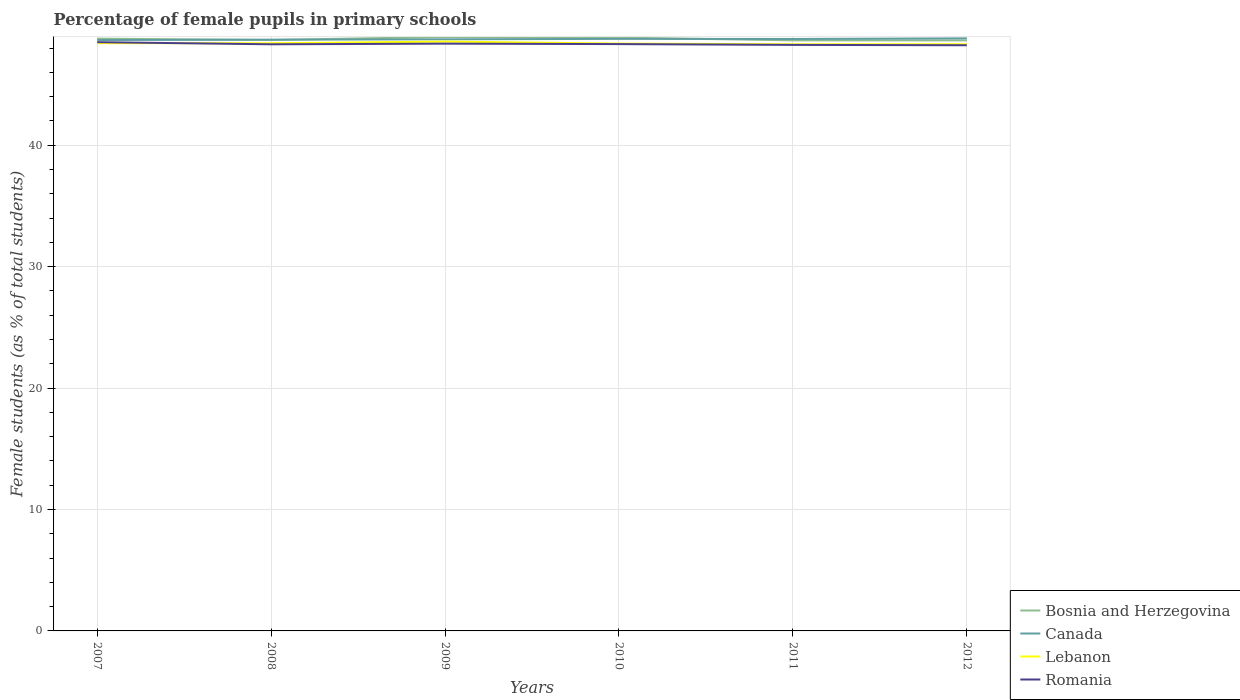How many different coloured lines are there?
Provide a succinct answer. 4. Does the line corresponding to Bosnia and Herzegovina intersect with the line corresponding to Romania?
Offer a very short reply. No. Is the number of lines equal to the number of legend labels?
Give a very brief answer. Yes. Across all years, what is the maximum percentage of female pupils in primary schools in Bosnia and Herzegovina?
Ensure brevity in your answer.  48.63. What is the total percentage of female pupils in primary schools in Romania in the graph?
Your response must be concise. 0.04. What is the difference between the highest and the second highest percentage of female pupils in primary schools in Romania?
Ensure brevity in your answer.  0.25. What is the difference between the highest and the lowest percentage of female pupils in primary schools in Lebanon?
Make the answer very short. 3. Is the percentage of female pupils in primary schools in Romania strictly greater than the percentage of female pupils in primary schools in Bosnia and Herzegovina over the years?
Offer a terse response. Yes. How many lines are there?
Offer a very short reply. 4. How many years are there in the graph?
Provide a succinct answer. 6. What is the difference between two consecutive major ticks on the Y-axis?
Ensure brevity in your answer.  10. How are the legend labels stacked?
Your answer should be very brief. Vertical. What is the title of the graph?
Make the answer very short. Percentage of female pupils in primary schools. What is the label or title of the Y-axis?
Provide a short and direct response. Female students (as % of total students). What is the Female students (as % of total students) of Bosnia and Herzegovina in 2007?
Keep it short and to the point. 48.77. What is the Female students (as % of total students) of Canada in 2007?
Your answer should be compact. 48.66. What is the Female students (as % of total students) in Lebanon in 2007?
Make the answer very short. 48.4. What is the Female students (as % of total students) in Romania in 2007?
Provide a short and direct response. 48.49. What is the Female students (as % of total students) of Bosnia and Herzegovina in 2008?
Keep it short and to the point. 48.67. What is the Female students (as % of total students) of Canada in 2008?
Your answer should be compact. 48.69. What is the Female students (as % of total students) in Lebanon in 2008?
Offer a very short reply. 48.4. What is the Female students (as % of total students) of Romania in 2008?
Your answer should be very brief. 48.31. What is the Female students (as % of total students) in Bosnia and Herzegovina in 2009?
Make the answer very short. 48.91. What is the Female students (as % of total students) in Canada in 2009?
Your answer should be compact. 48.72. What is the Female students (as % of total students) of Lebanon in 2009?
Your answer should be very brief. 48.53. What is the Female students (as % of total students) of Romania in 2009?
Make the answer very short. 48.36. What is the Female students (as % of total students) of Bosnia and Herzegovina in 2010?
Provide a short and direct response. 48.86. What is the Female students (as % of total students) of Canada in 2010?
Make the answer very short. 48.76. What is the Female students (as % of total students) in Lebanon in 2010?
Give a very brief answer. 48.37. What is the Female students (as % of total students) in Romania in 2010?
Provide a short and direct response. 48.33. What is the Female students (as % of total students) of Bosnia and Herzegovina in 2011?
Offer a very short reply. 48.63. What is the Female students (as % of total students) of Canada in 2011?
Ensure brevity in your answer.  48.75. What is the Female students (as % of total students) of Lebanon in 2011?
Keep it short and to the point. 48.31. What is the Female students (as % of total students) of Romania in 2011?
Your answer should be very brief. 48.26. What is the Female students (as % of total students) in Bosnia and Herzegovina in 2012?
Your response must be concise. 48.63. What is the Female students (as % of total students) in Canada in 2012?
Your response must be concise. 48.8. What is the Female students (as % of total students) of Lebanon in 2012?
Keep it short and to the point. 48.31. What is the Female students (as % of total students) of Romania in 2012?
Make the answer very short. 48.23. Across all years, what is the maximum Female students (as % of total students) in Bosnia and Herzegovina?
Provide a succinct answer. 48.91. Across all years, what is the maximum Female students (as % of total students) in Canada?
Keep it short and to the point. 48.8. Across all years, what is the maximum Female students (as % of total students) in Lebanon?
Provide a short and direct response. 48.53. Across all years, what is the maximum Female students (as % of total students) of Romania?
Make the answer very short. 48.49. Across all years, what is the minimum Female students (as % of total students) of Bosnia and Herzegovina?
Give a very brief answer. 48.63. Across all years, what is the minimum Female students (as % of total students) in Canada?
Your response must be concise. 48.66. Across all years, what is the minimum Female students (as % of total students) in Lebanon?
Provide a short and direct response. 48.31. Across all years, what is the minimum Female students (as % of total students) in Romania?
Your answer should be compact. 48.23. What is the total Female students (as % of total students) in Bosnia and Herzegovina in the graph?
Offer a terse response. 292.48. What is the total Female students (as % of total students) in Canada in the graph?
Your answer should be compact. 292.37. What is the total Female students (as % of total students) in Lebanon in the graph?
Offer a terse response. 290.33. What is the total Female students (as % of total students) of Romania in the graph?
Ensure brevity in your answer.  289.98. What is the difference between the Female students (as % of total students) of Bosnia and Herzegovina in 2007 and that in 2008?
Your answer should be compact. 0.1. What is the difference between the Female students (as % of total students) of Canada in 2007 and that in 2008?
Your answer should be very brief. -0.03. What is the difference between the Female students (as % of total students) in Lebanon in 2007 and that in 2008?
Provide a succinct answer. 0.01. What is the difference between the Female students (as % of total students) in Romania in 2007 and that in 2008?
Offer a terse response. 0.18. What is the difference between the Female students (as % of total students) of Bosnia and Herzegovina in 2007 and that in 2009?
Offer a very short reply. -0.14. What is the difference between the Female students (as % of total students) of Canada in 2007 and that in 2009?
Keep it short and to the point. -0.06. What is the difference between the Female students (as % of total students) of Lebanon in 2007 and that in 2009?
Your response must be concise. -0.13. What is the difference between the Female students (as % of total students) of Romania in 2007 and that in 2009?
Your response must be concise. 0.12. What is the difference between the Female students (as % of total students) of Bosnia and Herzegovina in 2007 and that in 2010?
Offer a very short reply. -0.09. What is the difference between the Female students (as % of total students) of Canada in 2007 and that in 2010?
Keep it short and to the point. -0.09. What is the difference between the Female students (as % of total students) of Lebanon in 2007 and that in 2010?
Ensure brevity in your answer.  0.04. What is the difference between the Female students (as % of total students) of Romania in 2007 and that in 2010?
Provide a short and direct response. 0.16. What is the difference between the Female students (as % of total students) in Bosnia and Herzegovina in 2007 and that in 2011?
Give a very brief answer. 0.14. What is the difference between the Female students (as % of total students) of Canada in 2007 and that in 2011?
Your answer should be very brief. -0.08. What is the difference between the Female students (as % of total students) in Lebanon in 2007 and that in 2011?
Your answer should be very brief. 0.09. What is the difference between the Female students (as % of total students) in Romania in 2007 and that in 2011?
Provide a short and direct response. 0.22. What is the difference between the Female students (as % of total students) in Bosnia and Herzegovina in 2007 and that in 2012?
Offer a terse response. 0.14. What is the difference between the Female students (as % of total students) of Canada in 2007 and that in 2012?
Make the answer very short. -0.14. What is the difference between the Female students (as % of total students) in Lebanon in 2007 and that in 2012?
Ensure brevity in your answer.  0.09. What is the difference between the Female students (as % of total students) of Romania in 2007 and that in 2012?
Offer a very short reply. 0.25. What is the difference between the Female students (as % of total students) of Bosnia and Herzegovina in 2008 and that in 2009?
Provide a succinct answer. -0.24. What is the difference between the Female students (as % of total students) in Canada in 2008 and that in 2009?
Ensure brevity in your answer.  -0.03. What is the difference between the Female students (as % of total students) of Lebanon in 2008 and that in 2009?
Ensure brevity in your answer.  -0.14. What is the difference between the Female students (as % of total students) of Romania in 2008 and that in 2009?
Ensure brevity in your answer.  -0.05. What is the difference between the Female students (as % of total students) in Bosnia and Herzegovina in 2008 and that in 2010?
Provide a succinct answer. -0.19. What is the difference between the Female students (as % of total students) of Canada in 2008 and that in 2010?
Offer a terse response. -0.07. What is the difference between the Female students (as % of total students) of Lebanon in 2008 and that in 2010?
Provide a short and direct response. 0.03. What is the difference between the Female students (as % of total students) of Romania in 2008 and that in 2010?
Make the answer very short. -0.02. What is the difference between the Female students (as % of total students) in Bosnia and Herzegovina in 2008 and that in 2011?
Your answer should be compact. 0.03. What is the difference between the Female students (as % of total students) in Canada in 2008 and that in 2011?
Keep it short and to the point. -0.06. What is the difference between the Female students (as % of total students) in Lebanon in 2008 and that in 2011?
Your answer should be compact. 0.08. What is the difference between the Female students (as % of total students) in Romania in 2008 and that in 2011?
Give a very brief answer. 0.05. What is the difference between the Female students (as % of total students) of Bosnia and Herzegovina in 2008 and that in 2012?
Offer a very short reply. 0.04. What is the difference between the Female students (as % of total students) in Canada in 2008 and that in 2012?
Provide a short and direct response. -0.11. What is the difference between the Female students (as % of total students) of Lebanon in 2008 and that in 2012?
Ensure brevity in your answer.  0.08. What is the difference between the Female students (as % of total students) in Romania in 2008 and that in 2012?
Your answer should be very brief. 0.08. What is the difference between the Female students (as % of total students) in Bosnia and Herzegovina in 2009 and that in 2010?
Make the answer very short. 0.05. What is the difference between the Female students (as % of total students) in Canada in 2009 and that in 2010?
Your answer should be very brief. -0.04. What is the difference between the Female students (as % of total students) in Lebanon in 2009 and that in 2010?
Your answer should be compact. 0.16. What is the difference between the Female students (as % of total students) in Romania in 2009 and that in 2010?
Give a very brief answer. 0.04. What is the difference between the Female students (as % of total students) in Bosnia and Herzegovina in 2009 and that in 2011?
Offer a very short reply. 0.28. What is the difference between the Female students (as % of total students) in Canada in 2009 and that in 2011?
Make the answer very short. -0.03. What is the difference between the Female students (as % of total students) in Lebanon in 2009 and that in 2011?
Provide a short and direct response. 0.22. What is the difference between the Female students (as % of total students) in Romania in 2009 and that in 2011?
Provide a succinct answer. 0.1. What is the difference between the Female students (as % of total students) of Bosnia and Herzegovina in 2009 and that in 2012?
Provide a succinct answer. 0.28. What is the difference between the Female students (as % of total students) in Canada in 2009 and that in 2012?
Your answer should be compact. -0.08. What is the difference between the Female students (as % of total students) of Lebanon in 2009 and that in 2012?
Offer a very short reply. 0.22. What is the difference between the Female students (as % of total students) of Romania in 2009 and that in 2012?
Offer a terse response. 0.13. What is the difference between the Female students (as % of total students) of Bosnia and Herzegovina in 2010 and that in 2011?
Provide a succinct answer. 0.23. What is the difference between the Female students (as % of total students) of Canada in 2010 and that in 2011?
Keep it short and to the point. 0.01. What is the difference between the Female students (as % of total students) in Lebanon in 2010 and that in 2011?
Ensure brevity in your answer.  0.06. What is the difference between the Female students (as % of total students) of Romania in 2010 and that in 2011?
Your response must be concise. 0.07. What is the difference between the Female students (as % of total students) of Bosnia and Herzegovina in 2010 and that in 2012?
Provide a succinct answer. 0.23. What is the difference between the Female students (as % of total students) of Canada in 2010 and that in 2012?
Make the answer very short. -0.04. What is the difference between the Female students (as % of total students) of Lebanon in 2010 and that in 2012?
Ensure brevity in your answer.  0.05. What is the difference between the Female students (as % of total students) of Romania in 2010 and that in 2012?
Your response must be concise. 0.1. What is the difference between the Female students (as % of total students) of Bosnia and Herzegovina in 2011 and that in 2012?
Provide a short and direct response. 0. What is the difference between the Female students (as % of total students) of Canada in 2011 and that in 2012?
Your response must be concise. -0.05. What is the difference between the Female students (as % of total students) of Lebanon in 2011 and that in 2012?
Give a very brief answer. -0. What is the difference between the Female students (as % of total students) in Romania in 2011 and that in 2012?
Your answer should be very brief. 0.03. What is the difference between the Female students (as % of total students) of Bosnia and Herzegovina in 2007 and the Female students (as % of total students) of Canada in 2008?
Offer a terse response. 0.08. What is the difference between the Female students (as % of total students) in Bosnia and Herzegovina in 2007 and the Female students (as % of total students) in Lebanon in 2008?
Give a very brief answer. 0.38. What is the difference between the Female students (as % of total students) of Bosnia and Herzegovina in 2007 and the Female students (as % of total students) of Romania in 2008?
Offer a terse response. 0.46. What is the difference between the Female students (as % of total students) in Canada in 2007 and the Female students (as % of total students) in Lebanon in 2008?
Give a very brief answer. 0.27. What is the difference between the Female students (as % of total students) of Canada in 2007 and the Female students (as % of total students) of Romania in 2008?
Offer a terse response. 0.35. What is the difference between the Female students (as % of total students) of Lebanon in 2007 and the Female students (as % of total students) of Romania in 2008?
Provide a short and direct response. 0.1. What is the difference between the Female students (as % of total students) of Bosnia and Herzegovina in 2007 and the Female students (as % of total students) of Canada in 2009?
Keep it short and to the point. 0.05. What is the difference between the Female students (as % of total students) of Bosnia and Herzegovina in 2007 and the Female students (as % of total students) of Lebanon in 2009?
Your answer should be very brief. 0.24. What is the difference between the Female students (as % of total students) in Bosnia and Herzegovina in 2007 and the Female students (as % of total students) in Romania in 2009?
Provide a short and direct response. 0.41. What is the difference between the Female students (as % of total students) in Canada in 2007 and the Female students (as % of total students) in Lebanon in 2009?
Provide a succinct answer. 0.13. What is the difference between the Female students (as % of total students) in Canada in 2007 and the Female students (as % of total students) in Romania in 2009?
Give a very brief answer. 0.3. What is the difference between the Female students (as % of total students) in Lebanon in 2007 and the Female students (as % of total students) in Romania in 2009?
Offer a very short reply. 0.04. What is the difference between the Female students (as % of total students) of Bosnia and Herzegovina in 2007 and the Female students (as % of total students) of Canada in 2010?
Ensure brevity in your answer.  0.02. What is the difference between the Female students (as % of total students) of Bosnia and Herzegovina in 2007 and the Female students (as % of total students) of Lebanon in 2010?
Ensure brevity in your answer.  0.4. What is the difference between the Female students (as % of total students) of Bosnia and Herzegovina in 2007 and the Female students (as % of total students) of Romania in 2010?
Keep it short and to the point. 0.45. What is the difference between the Female students (as % of total students) of Canada in 2007 and the Female students (as % of total students) of Lebanon in 2010?
Make the answer very short. 0.29. What is the difference between the Female students (as % of total students) in Canada in 2007 and the Female students (as % of total students) in Romania in 2010?
Provide a short and direct response. 0.34. What is the difference between the Female students (as % of total students) in Lebanon in 2007 and the Female students (as % of total students) in Romania in 2010?
Make the answer very short. 0.08. What is the difference between the Female students (as % of total students) in Bosnia and Herzegovina in 2007 and the Female students (as % of total students) in Canada in 2011?
Keep it short and to the point. 0.03. What is the difference between the Female students (as % of total students) in Bosnia and Herzegovina in 2007 and the Female students (as % of total students) in Lebanon in 2011?
Your answer should be compact. 0.46. What is the difference between the Female students (as % of total students) in Bosnia and Herzegovina in 2007 and the Female students (as % of total students) in Romania in 2011?
Your response must be concise. 0.51. What is the difference between the Female students (as % of total students) in Canada in 2007 and the Female students (as % of total students) in Lebanon in 2011?
Your answer should be very brief. 0.35. What is the difference between the Female students (as % of total students) in Canada in 2007 and the Female students (as % of total students) in Romania in 2011?
Provide a short and direct response. 0.4. What is the difference between the Female students (as % of total students) in Lebanon in 2007 and the Female students (as % of total students) in Romania in 2011?
Your answer should be compact. 0.14. What is the difference between the Female students (as % of total students) of Bosnia and Herzegovina in 2007 and the Female students (as % of total students) of Canada in 2012?
Your answer should be very brief. -0.03. What is the difference between the Female students (as % of total students) of Bosnia and Herzegovina in 2007 and the Female students (as % of total students) of Lebanon in 2012?
Offer a very short reply. 0.46. What is the difference between the Female students (as % of total students) of Bosnia and Herzegovina in 2007 and the Female students (as % of total students) of Romania in 2012?
Keep it short and to the point. 0.54. What is the difference between the Female students (as % of total students) of Canada in 2007 and the Female students (as % of total students) of Lebanon in 2012?
Your response must be concise. 0.35. What is the difference between the Female students (as % of total students) of Canada in 2007 and the Female students (as % of total students) of Romania in 2012?
Your response must be concise. 0.43. What is the difference between the Female students (as % of total students) in Lebanon in 2007 and the Female students (as % of total students) in Romania in 2012?
Provide a short and direct response. 0.17. What is the difference between the Female students (as % of total students) in Bosnia and Herzegovina in 2008 and the Female students (as % of total students) in Canada in 2009?
Your response must be concise. -0.05. What is the difference between the Female students (as % of total students) of Bosnia and Herzegovina in 2008 and the Female students (as % of total students) of Lebanon in 2009?
Your answer should be compact. 0.14. What is the difference between the Female students (as % of total students) of Bosnia and Herzegovina in 2008 and the Female students (as % of total students) of Romania in 2009?
Offer a very short reply. 0.31. What is the difference between the Female students (as % of total students) in Canada in 2008 and the Female students (as % of total students) in Lebanon in 2009?
Keep it short and to the point. 0.16. What is the difference between the Female students (as % of total students) of Canada in 2008 and the Female students (as % of total students) of Romania in 2009?
Make the answer very short. 0.33. What is the difference between the Female students (as % of total students) in Lebanon in 2008 and the Female students (as % of total students) in Romania in 2009?
Offer a very short reply. 0.03. What is the difference between the Female students (as % of total students) of Bosnia and Herzegovina in 2008 and the Female students (as % of total students) of Canada in 2010?
Provide a succinct answer. -0.09. What is the difference between the Female students (as % of total students) in Bosnia and Herzegovina in 2008 and the Female students (as % of total students) in Lebanon in 2010?
Offer a very short reply. 0.3. What is the difference between the Female students (as % of total students) in Bosnia and Herzegovina in 2008 and the Female students (as % of total students) in Romania in 2010?
Make the answer very short. 0.34. What is the difference between the Female students (as % of total students) in Canada in 2008 and the Female students (as % of total students) in Lebanon in 2010?
Your answer should be compact. 0.32. What is the difference between the Female students (as % of total students) in Canada in 2008 and the Female students (as % of total students) in Romania in 2010?
Keep it short and to the point. 0.36. What is the difference between the Female students (as % of total students) of Lebanon in 2008 and the Female students (as % of total students) of Romania in 2010?
Your answer should be very brief. 0.07. What is the difference between the Female students (as % of total students) of Bosnia and Herzegovina in 2008 and the Female students (as % of total students) of Canada in 2011?
Your answer should be compact. -0.08. What is the difference between the Female students (as % of total students) of Bosnia and Herzegovina in 2008 and the Female students (as % of total students) of Lebanon in 2011?
Offer a very short reply. 0.36. What is the difference between the Female students (as % of total students) in Bosnia and Herzegovina in 2008 and the Female students (as % of total students) in Romania in 2011?
Ensure brevity in your answer.  0.41. What is the difference between the Female students (as % of total students) in Canada in 2008 and the Female students (as % of total students) in Lebanon in 2011?
Ensure brevity in your answer.  0.38. What is the difference between the Female students (as % of total students) in Canada in 2008 and the Female students (as % of total students) in Romania in 2011?
Provide a succinct answer. 0.43. What is the difference between the Female students (as % of total students) in Lebanon in 2008 and the Female students (as % of total students) in Romania in 2011?
Provide a succinct answer. 0.14. What is the difference between the Female students (as % of total students) of Bosnia and Herzegovina in 2008 and the Female students (as % of total students) of Canada in 2012?
Your answer should be very brief. -0.13. What is the difference between the Female students (as % of total students) in Bosnia and Herzegovina in 2008 and the Female students (as % of total students) in Lebanon in 2012?
Provide a short and direct response. 0.35. What is the difference between the Female students (as % of total students) of Bosnia and Herzegovina in 2008 and the Female students (as % of total students) of Romania in 2012?
Provide a short and direct response. 0.44. What is the difference between the Female students (as % of total students) of Canada in 2008 and the Female students (as % of total students) of Lebanon in 2012?
Provide a short and direct response. 0.37. What is the difference between the Female students (as % of total students) in Canada in 2008 and the Female students (as % of total students) in Romania in 2012?
Your answer should be compact. 0.46. What is the difference between the Female students (as % of total students) in Lebanon in 2008 and the Female students (as % of total students) in Romania in 2012?
Provide a short and direct response. 0.17. What is the difference between the Female students (as % of total students) in Bosnia and Herzegovina in 2009 and the Female students (as % of total students) in Canada in 2010?
Provide a short and direct response. 0.16. What is the difference between the Female students (as % of total students) of Bosnia and Herzegovina in 2009 and the Female students (as % of total students) of Lebanon in 2010?
Provide a short and direct response. 0.54. What is the difference between the Female students (as % of total students) in Bosnia and Herzegovina in 2009 and the Female students (as % of total students) in Romania in 2010?
Provide a short and direct response. 0.58. What is the difference between the Female students (as % of total students) of Canada in 2009 and the Female students (as % of total students) of Lebanon in 2010?
Offer a very short reply. 0.35. What is the difference between the Female students (as % of total students) of Canada in 2009 and the Female students (as % of total students) of Romania in 2010?
Offer a terse response. 0.39. What is the difference between the Female students (as % of total students) in Lebanon in 2009 and the Female students (as % of total students) in Romania in 2010?
Give a very brief answer. 0.21. What is the difference between the Female students (as % of total students) in Bosnia and Herzegovina in 2009 and the Female students (as % of total students) in Canada in 2011?
Provide a succinct answer. 0.17. What is the difference between the Female students (as % of total students) of Bosnia and Herzegovina in 2009 and the Female students (as % of total students) of Lebanon in 2011?
Your response must be concise. 0.6. What is the difference between the Female students (as % of total students) in Bosnia and Herzegovina in 2009 and the Female students (as % of total students) in Romania in 2011?
Your response must be concise. 0.65. What is the difference between the Female students (as % of total students) of Canada in 2009 and the Female students (as % of total students) of Lebanon in 2011?
Make the answer very short. 0.41. What is the difference between the Female students (as % of total students) of Canada in 2009 and the Female students (as % of total students) of Romania in 2011?
Ensure brevity in your answer.  0.46. What is the difference between the Female students (as % of total students) of Lebanon in 2009 and the Female students (as % of total students) of Romania in 2011?
Ensure brevity in your answer.  0.27. What is the difference between the Female students (as % of total students) in Bosnia and Herzegovina in 2009 and the Female students (as % of total students) in Canada in 2012?
Provide a short and direct response. 0.11. What is the difference between the Female students (as % of total students) of Bosnia and Herzegovina in 2009 and the Female students (as % of total students) of Lebanon in 2012?
Ensure brevity in your answer.  0.6. What is the difference between the Female students (as % of total students) of Bosnia and Herzegovina in 2009 and the Female students (as % of total students) of Romania in 2012?
Offer a terse response. 0.68. What is the difference between the Female students (as % of total students) of Canada in 2009 and the Female students (as % of total students) of Lebanon in 2012?
Give a very brief answer. 0.41. What is the difference between the Female students (as % of total students) of Canada in 2009 and the Female students (as % of total students) of Romania in 2012?
Make the answer very short. 0.49. What is the difference between the Female students (as % of total students) in Lebanon in 2009 and the Female students (as % of total students) in Romania in 2012?
Your answer should be very brief. 0.3. What is the difference between the Female students (as % of total students) in Bosnia and Herzegovina in 2010 and the Female students (as % of total students) in Canada in 2011?
Give a very brief answer. 0.11. What is the difference between the Female students (as % of total students) of Bosnia and Herzegovina in 2010 and the Female students (as % of total students) of Lebanon in 2011?
Your answer should be compact. 0.55. What is the difference between the Female students (as % of total students) of Bosnia and Herzegovina in 2010 and the Female students (as % of total students) of Romania in 2011?
Offer a very short reply. 0.6. What is the difference between the Female students (as % of total students) of Canada in 2010 and the Female students (as % of total students) of Lebanon in 2011?
Your response must be concise. 0.44. What is the difference between the Female students (as % of total students) of Canada in 2010 and the Female students (as % of total students) of Romania in 2011?
Provide a succinct answer. 0.49. What is the difference between the Female students (as % of total students) in Lebanon in 2010 and the Female students (as % of total students) in Romania in 2011?
Provide a short and direct response. 0.11. What is the difference between the Female students (as % of total students) of Bosnia and Herzegovina in 2010 and the Female students (as % of total students) of Canada in 2012?
Provide a succinct answer. 0.06. What is the difference between the Female students (as % of total students) of Bosnia and Herzegovina in 2010 and the Female students (as % of total students) of Lebanon in 2012?
Ensure brevity in your answer.  0.54. What is the difference between the Female students (as % of total students) in Bosnia and Herzegovina in 2010 and the Female students (as % of total students) in Romania in 2012?
Your answer should be very brief. 0.63. What is the difference between the Female students (as % of total students) of Canada in 2010 and the Female students (as % of total students) of Lebanon in 2012?
Offer a very short reply. 0.44. What is the difference between the Female students (as % of total students) in Canada in 2010 and the Female students (as % of total students) in Romania in 2012?
Your response must be concise. 0.52. What is the difference between the Female students (as % of total students) in Lebanon in 2010 and the Female students (as % of total students) in Romania in 2012?
Provide a succinct answer. 0.14. What is the difference between the Female students (as % of total students) of Bosnia and Herzegovina in 2011 and the Female students (as % of total students) of Canada in 2012?
Keep it short and to the point. -0.16. What is the difference between the Female students (as % of total students) in Bosnia and Herzegovina in 2011 and the Female students (as % of total students) in Lebanon in 2012?
Your response must be concise. 0.32. What is the difference between the Female students (as % of total students) in Bosnia and Herzegovina in 2011 and the Female students (as % of total students) in Romania in 2012?
Offer a very short reply. 0.4. What is the difference between the Female students (as % of total students) in Canada in 2011 and the Female students (as % of total students) in Lebanon in 2012?
Your response must be concise. 0.43. What is the difference between the Female students (as % of total students) of Canada in 2011 and the Female students (as % of total students) of Romania in 2012?
Your answer should be very brief. 0.52. What is the difference between the Female students (as % of total students) of Lebanon in 2011 and the Female students (as % of total students) of Romania in 2012?
Your answer should be very brief. 0.08. What is the average Female students (as % of total students) in Bosnia and Herzegovina per year?
Offer a terse response. 48.75. What is the average Female students (as % of total students) in Canada per year?
Give a very brief answer. 48.73. What is the average Female students (as % of total students) in Lebanon per year?
Provide a succinct answer. 48.39. What is the average Female students (as % of total students) in Romania per year?
Your answer should be compact. 48.33. In the year 2007, what is the difference between the Female students (as % of total students) of Bosnia and Herzegovina and Female students (as % of total students) of Canada?
Ensure brevity in your answer.  0.11. In the year 2007, what is the difference between the Female students (as % of total students) of Bosnia and Herzegovina and Female students (as % of total students) of Lebanon?
Give a very brief answer. 0.37. In the year 2007, what is the difference between the Female students (as % of total students) of Bosnia and Herzegovina and Female students (as % of total students) of Romania?
Ensure brevity in your answer.  0.29. In the year 2007, what is the difference between the Female students (as % of total students) of Canada and Female students (as % of total students) of Lebanon?
Ensure brevity in your answer.  0.26. In the year 2007, what is the difference between the Female students (as % of total students) of Canada and Female students (as % of total students) of Romania?
Your response must be concise. 0.18. In the year 2007, what is the difference between the Female students (as % of total students) in Lebanon and Female students (as % of total students) in Romania?
Offer a very short reply. -0.08. In the year 2008, what is the difference between the Female students (as % of total students) in Bosnia and Herzegovina and Female students (as % of total students) in Canada?
Offer a very short reply. -0.02. In the year 2008, what is the difference between the Female students (as % of total students) of Bosnia and Herzegovina and Female students (as % of total students) of Lebanon?
Provide a short and direct response. 0.27. In the year 2008, what is the difference between the Female students (as % of total students) of Bosnia and Herzegovina and Female students (as % of total students) of Romania?
Offer a terse response. 0.36. In the year 2008, what is the difference between the Female students (as % of total students) in Canada and Female students (as % of total students) in Lebanon?
Offer a very short reply. 0.29. In the year 2008, what is the difference between the Female students (as % of total students) in Canada and Female students (as % of total students) in Romania?
Offer a terse response. 0.38. In the year 2008, what is the difference between the Female students (as % of total students) in Lebanon and Female students (as % of total students) in Romania?
Your answer should be very brief. 0.09. In the year 2009, what is the difference between the Female students (as % of total students) in Bosnia and Herzegovina and Female students (as % of total students) in Canada?
Offer a very short reply. 0.19. In the year 2009, what is the difference between the Female students (as % of total students) of Bosnia and Herzegovina and Female students (as % of total students) of Lebanon?
Your answer should be very brief. 0.38. In the year 2009, what is the difference between the Female students (as % of total students) in Bosnia and Herzegovina and Female students (as % of total students) in Romania?
Your answer should be compact. 0.55. In the year 2009, what is the difference between the Female students (as % of total students) in Canada and Female students (as % of total students) in Lebanon?
Your response must be concise. 0.19. In the year 2009, what is the difference between the Female students (as % of total students) in Canada and Female students (as % of total students) in Romania?
Make the answer very short. 0.36. In the year 2009, what is the difference between the Female students (as % of total students) in Lebanon and Female students (as % of total students) in Romania?
Keep it short and to the point. 0.17. In the year 2010, what is the difference between the Female students (as % of total students) of Bosnia and Herzegovina and Female students (as % of total students) of Canada?
Your answer should be very brief. 0.1. In the year 2010, what is the difference between the Female students (as % of total students) in Bosnia and Herzegovina and Female students (as % of total students) in Lebanon?
Make the answer very short. 0.49. In the year 2010, what is the difference between the Female students (as % of total students) in Bosnia and Herzegovina and Female students (as % of total students) in Romania?
Keep it short and to the point. 0.53. In the year 2010, what is the difference between the Female students (as % of total students) of Canada and Female students (as % of total students) of Lebanon?
Your response must be concise. 0.39. In the year 2010, what is the difference between the Female students (as % of total students) in Canada and Female students (as % of total students) in Romania?
Keep it short and to the point. 0.43. In the year 2010, what is the difference between the Female students (as % of total students) in Lebanon and Female students (as % of total students) in Romania?
Provide a succinct answer. 0.04. In the year 2011, what is the difference between the Female students (as % of total students) in Bosnia and Herzegovina and Female students (as % of total students) in Canada?
Provide a short and direct response. -0.11. In the year 2011, what is the difference between the Female students (as % of total students) in Bosnia and Herzegovina and Female students (as % of total students) in Lebanon?
Keep it short and to the point. 0.32. In the year 2011, what is the difference between the Female students (as % of total students) in Bosnia and Herzegovina and Female students (as % of total students) in Romania?
Keep it short and to the point. 0.37. In the year 2011, what is the difference between the Female students (as % of total students) of Canada and Female students (as % of total students) of Lebanon?
Your answer should be very brief. 0.43. In the year 2011, what is the difference between the Female students (as % of total students) in Canada and Female students (as % of total students) in Romania?
Your response must be concise. 0.49. In the year 2011, what is the difference between the Female students (as % of total students) in Lebanon and Female students (as % of total students) in Romania?
Keep it short and to the point. 0.05. In the year 2012, what is the difference between the Female students (as % of total students) of Bosnia and Herzegovina and Female students (as % of total students) of Canada?
Provide a succinct answer. -0.17. In the year 2012, what is the difference between the Female students (as % of total students) of Bosnia and Herzegovina and Female students (as % of total students) of Lebanon?
Keep it short and to the point. 0.32. In the year 2012, what is the difference between the Female students (as % of total students) of Bosnia and Herzegovina and Female students (as % of total students) of Romania?
Your answer should be compact. 0.4. In the year 2012, what is the difference between the Female students (as % of total students) of Canada and Female students (as % of total students) of Lebanon?
Give a very brief answer. 0.48. In the year 2012, what is the difference between the Female students (as % of total students) in Canada and Female students (as % of total students) in Romania?
Your answer should be very brief. 0.57. In the year 2012, what is the difference between the Female students (as % of total students) in Lebanon and Female students (as % of total students) in Romania?
Provide a short and direct response. 0.08. What is the ratio of the Female students (as % of total students) in Bosnia and Herzegovina in 2007 to that in 2008?
Your answer should be very brief. 1. What is the ratio of the Female students (as % of total students) of Canada in 2007 to that in 2008?
Make the answer very short. 1. What is the ratio of the Female students (as % of total students) in Lebanon in 2007 to that in 2008?
Keep it short and to the point. 1. What is the ratio of the Female students (as % of total students) in Romania in 2007 to that in 2008?
Offer a terse response. 1. What is the ratio of the Female students (as % of total students) of Bosnia and Herzegovina in 2007 to that in 2009?
Make the answer very short. 1. What is the ratio of the Female students (as % of total students) in Canada in 2007 to that in 2010?
Offer a terse response. 1. What is the ratio of the Female students (as % of total students) in Romania in 2007 to that in 2011?
Your answer should be compact. 1. What is the ratio of the Female students (as % of total students) of Bosnia and Herzegovina in 2007 to that in 2012?
Your answer should be very brief. 1. What is the ratio of the Female students (as % of total students) in Canada in 2007 to that in 2012?
Ensure brevity in your answer.  1. What is the ratio of the Female students (as % of total students) in Romania in 2007 to that in 2012?
Offer a terse response. 1.01. What is the ratio of the Female students (as % of total students) in Canada in 2008 to that in 2009?
Offer a very short reply. 1. What is the ratio of the Female students (as % of total students) in Bosnia and Herzegovina in 2008 to that in 2010?
Offer a very short reply. 1. What is the ratio of the Female students (as % of total students) of Lebanon in 2008 to that in 2010?
Give a very brief answer. 1. What is the ratio of the Female students (as % of total students) of Romania in 2008 to that in 2010?
Ensure brevity in your answer.  1. What is the ratio of the Female students (as % of total students) of Bosnia and Herzegovina in 2008 to that in 2011?
Your response must be concise. 1. What is the ratio of the Female students (as % of total students) of Canada in 2008 to that in 2011?
Make the answer very short. 1. What is the ratio of the Female students (as % of total students) in Lebanon in 2008 to that in 2011?
Keep it short and to the point. 1. What is the ratio of the Female students (as % of total students) of Romania in 2008 to that in 2012?
Your response must be concise. 1. What is the ratio of the Female students (as % of total students) of Canada in 2009 to that in 2010?
Your answer should be very brief. 1. What is the ratio of the Female students (as % of total students) of Bosnia and Herzegovina in 2009 to that in 2011?
Keep it short and to the point. 1.01. What is the ratio of the Female students (as % of total students) of Canada in 2009 to that in 2011?
Make the answer very short. 1. What is the ratio of the Female students (as % of total students) of Bosnia and Herzegovina in 2009 to that in 2012?
Give a very brief answer. 1.01. What is the ratio of the Female students (as % of total students) in Canada in 2009 to that in 2012?
Your answer should be very brief. 1. What is the ratio of the Female students (as % of total students) of Romania in 2009 to that in 2012?
Provide a short and direct response. 1. What is the ratio of the Female students (as % of total students) in Bosnia and Herzegovina in 2010 to that in 2011?
Provide a succinct answer. 1. What is the ratio of the Female students (as % of total students) in Canada in 2010 to that in 2011?
Provide a short and direct response. 1. What is the ratio of the Female students (as % of total students) of Lebanon in 2010 to that in 2011?
Offer a very short reply. 1. What is the ratio of the Female students (as % of total students) of Canada in 2010 to that in 2012?
Offer a terse response. 1. What is the ratio of the Female students (as % of total students) of Lebanon in 2010 to that in 2012?
Offer a very short reply. 1. What is the ratio of the Female students (as % of total students) of Romania in 2010 to that in 2012?
Offer a very short reply. 1. What is the ratio of the Female students (as % of total students) in Romania in 2011 to that in 2012?
Provide a succinct answer. 1. What is the difference between the highest and the second highest Female students (as % of total students) in Bosnia and Herzegovina?
Your response must be concise. 0.05. What is the difference between the highest and the second highest Female students (as % of total students) of Canada?
Offer a terse response. 0.04. What is the difference between the highest and the second highest Female students (as % of total students) of Lebanon?
Offer a terse response. 0.13. What is the difference between the highest and the second highest Female students (as % of total students) of Romania?
Provide a short and direct response. 0.12. What is the difference between the highest and the lowest Female students (as % of total students) in Bosnia and Herzegovina?
Offer a very short reply. 0.28. What is the difference between the highest and the lowest Female students (as % of total students) in Canada?
Provide a succinct answer. 0.14. What is the difference between the highest and the lowest Female students (as % of total students) of Lebanon?
Your response must be concise. 0.22. What is the difference between the highest and the lowest Female students (as % of total students) of Romania?
Ensure brevity in your answer.  0.25. 